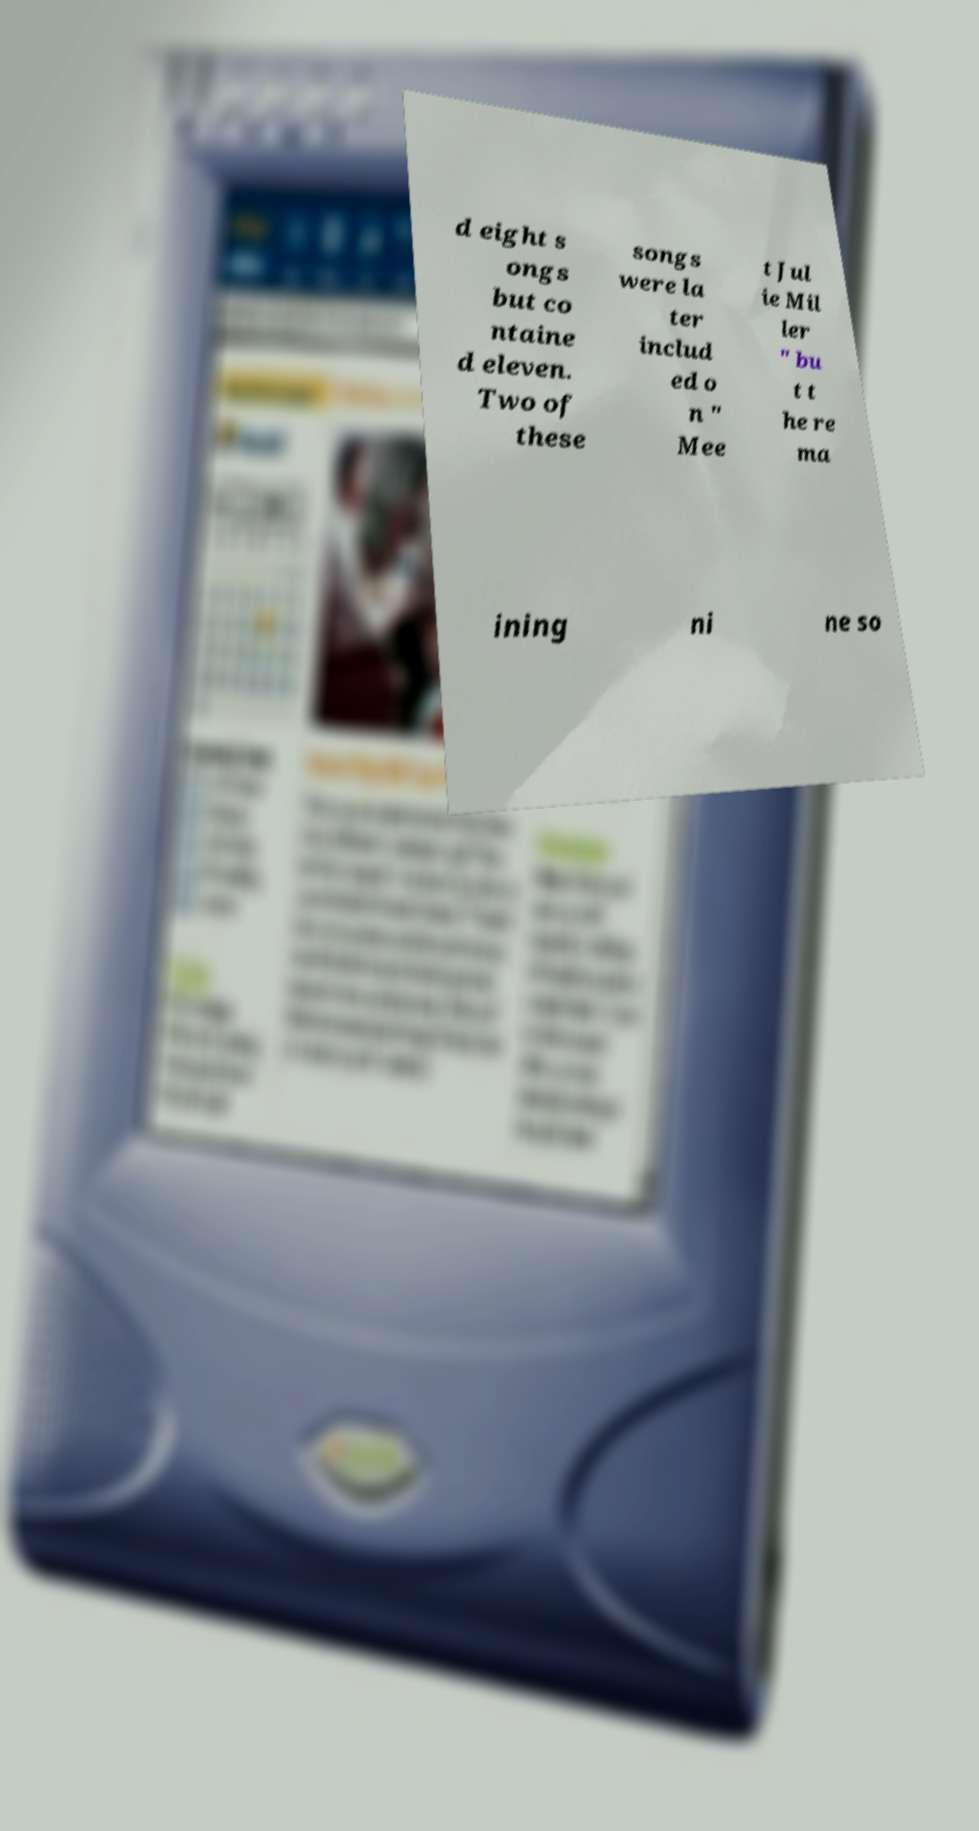Could you assist in decoding the text presented in this image and type it out clearly? d eight s ongs but co ntaine d eleven. Two of these songs were la ter includ ed o n " Mee t Jul ie Mil ler " bu t t he re ma ining ni ne so 